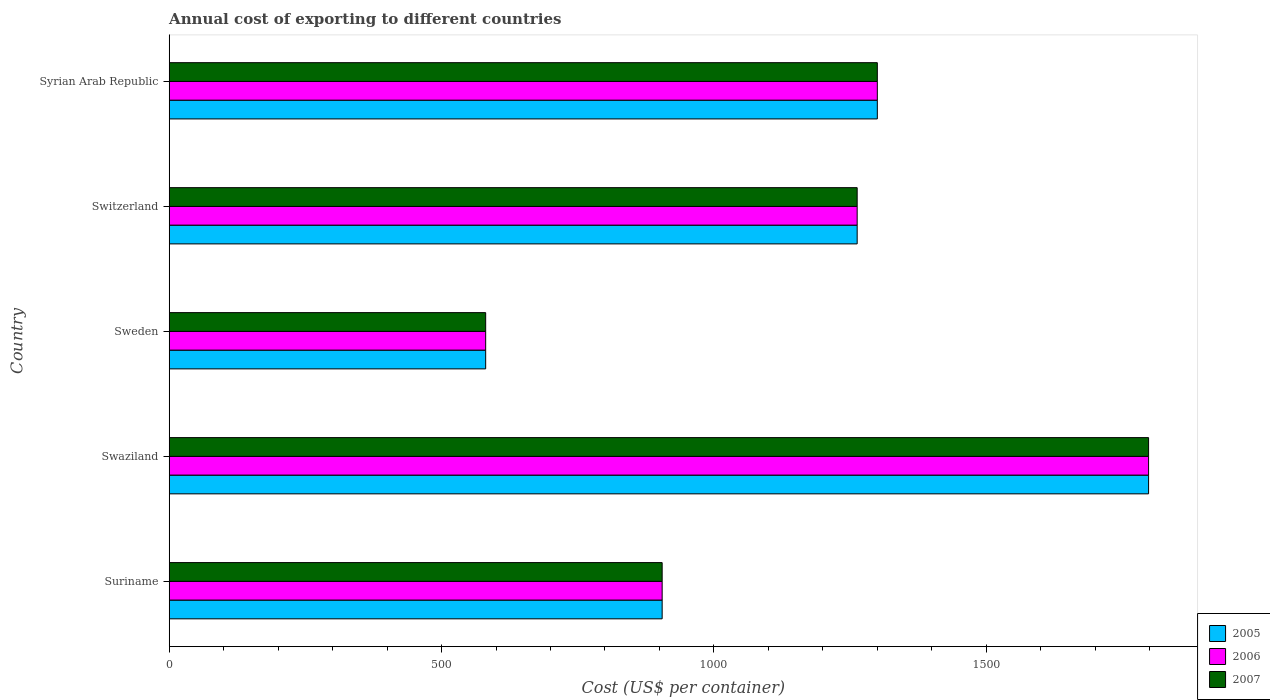Are the number of bars per tick equal to the number of legend labels?
Ensure brevity in your answer.  Yes. How many bars are there on the 3rd tick from the top?
Your response must be concise. 3. How many bars are there on the 5th tick from the bottom?
Your answer should be very brief. 3. In how many cases, is the number of bars for a given country not equal to the number of legend labels?
Provide a succinct answer. 0. What is the total annual cost of exporting in 2005 in Sweden?
Your response must be concise. 581. Across all countries, what is the maximum total annual cost of exporting in 2006?
Your response must be concise. 1798. Across all countries, what is the minimum total annual cost of exporting in 2006?
Your answer should be compact. 581. In which country was the total annual cost of exporting in 2007 maximum?
Ensure brevity in your answer.  Swaziland. What is the total total annual cost of exporting in 2005 in the graph?
Provide a succinct answer. 5847. What is the difference between the total annual cost of exporting in 2007 in Switzerland and that in Syrian Arab Republic?
Provide a succinct answer. -37. What is the difference between the total annual cost of exporting in 2006 in Swaziland and the total annual cost of exporting in 2005 in Sweden?
Offer a terse response. 1217. What is the average total annual cost of exporting in 2006 per country?
Keep it short and to the point. 1169.4. What is the difference between the total annual cost of exporting in 2005 and total annual cost of exporting in 2007 in Sweden?
Provide a succinct answer. 0. In how many countries, is the total annual cost of exporting in 2007 greater than 1600 US$?
Provide a succinct answer. 1. What is the ratio of the total annual cost of exporting in 2005 in Switzerland to that in Syrian Arab Republic?
Provide a short and direct response. 0.97. Is the total annual cost of exporting in 2007 in Suriname less than that in Swaziland?
Your response must be concise. Yes. Is the difference between the total annual cost of exporting in 2005 in Suriname and Syrian Arab Republic greater than the difference between the total annual cost of exporting in 2007 in Suriname and Syrian Arab Republic?
Offer a terse response. No. What is the difference between the highest and the second highest total annual cost of exporting in 2006?
Provide a short and direct response. 498. What is the difference between the highest and the lowest total annual cost of exporting in 2007?
Make the answer very short. 1217. In how many countries, is the total annual cost of exporting in 2005 greater than the average total annual cost of exporting in 2005 taken over all countries?
Provide a succinct answer. 3. Is the sum of the total annual cost of exporting in 2007 in Suriname and Sweden greater than the maximum total annual cost of exporting in 2005 across all countries?
Your answer should be compact. No. What does the 3rd bar from the top in Switzerland represents?
Your answer should be very brief. 2005. What does the 2nd bar from the bottom in Switzerland represents?
Your answer should be very brief. 2006. Does the graph contain any zero values?
Provide a succinct answer. No. Does the graph contain grids?
Offer a terse response. No. How are the legend labels stacked?
Keep it short and to the point. Vertical. What is the title of the graph?
Offer a very short reply. Annual cost of exporting to different countries. What is the label or title of the X-axis?
Make the answer very short. Cost (US$ per container). What is the label or title of the Y-axis?
Make the answer very short. Country. What is the Cost (US$ per container) in 2005 in Suriname?
Ensure brevity in your answer.  905. What is the Cost (US$ per container) in 2006 in Suriname?
Give a very brief answer. 905. What is the Cost (US$ per container) of 2007 in Suriname?
Your answer should be compact. 905. What is the Cost (US$ per container) of 2005 in Swaziland?
Ensure brevity in your answer.  1798. What is the Cost (US$ per container) in 2006 in Swaziland?
Offer a very short reply. 1798. What is the Cost (US$ per container) of 2007 in Swaziland?
Keep it short and to the point. 1798. What is the Cost (US$ per container) of 2005 in Sweden?
Offer a terse response. 581. What is the Cost (US$ per container) in 2006 in Sweden?
Your response must be concise. 581. What is the Cost (US$ per container) in 2007 in Sweden?
Your answer should be compact. 581. What is the Cost (US$ per container) in 2005 in Switzerland?
Give a very brief answer. 1263. What is the Cost (US$ per container) in 2006 in Switzerland?
Ensure brevity in your answer.  1263. What is the Cost (US$ per container) of 2007 in Switzerland?
Provide a succinct answer. 1263. What is the Cost (US$ per container) in 2005 in Syrian Arab Republic?
Provide a short and direct response. 1300. What is the Cost (US$ per container) of 2006 in Syrian Arab Republic?
Keep it short and to the point. 1300. What is the Cost (US$ per container) of 2007 in Syrian Arab Republic?
Your response must be concise. 1300. Across all countries, what is the maximum Cost (US$ per container) in 2005?
Give a very brief answer. 1798. Across all countries, what is the maximum Cost (US$ per container) of 2006?
Offer a terse response. 1798. Across all countries, what is the maximum Cost (US$ per container) in 2007?
Keep it short and to the point. 1798. Across all countries, what is the minimum Cost (US$ per container) of 2005?
Make the answer very short. 581. Across all countries, what is the minimum Cost (US$ per container) in 2006?
Offer a very short reply. 581. Across all countries, what is the minimum Cost (US$ per container) of 2007?
Provide a succinct answer. 581. What is the total Cost (US$ per container) in 2005 in the graph?
Ensure brevity in your answer.  5847. What is the total Cost (US$ per container) of 2006 in the graph?
Provide a short and direct response. 5847. What is the total Cost (US$ per container) in 2007 in the graph?
Ensure brevity in your answer.  5847. What is the difference between the Cost (US$ per container) in 2005 in Suriname and that in Swaziland?
Ensure brevity in your answer.  -893. What is the difference between the Cost (US$ per container) of 2006 in Suriname and that in Swaziland?
Provide a short and direct response. -893. What is the difference between the Cost (US$ per container) of 2007 in Suriname and that in Swaziland?
Make the answer very short. -893. What is the difference between the Cost (US$ per container) of 2005 in Suriname and that in Sweden?
Keep it short and to the point. 324. What is the difference between the Cost (US$ per container) in 2006 in Suriname and that in Sweden?
Provide a succinct answer. 324. What is the difference between the Cost (US$ per container) in 2007 in Suriname and that in Sweden?
Keep it short and to the point. 324. What is the difference between the Cost (US$ per container) in 2005 in Suriname and that in Switzerland?
Ensure brevity in your answer.  -358. What is the difference between the Cost (US$ per container) in 2006 in Suriname and that in Switzerland?
Give a very brief answer. -358. What is the difference between the Cost (US$ per container) in 2007 in Suriname and that in Switzerland?
Ensure brevity in your answer.  -358. What is the difference between the Cost (US$ per container) in 2005 in Suriname and that in Syrian Arab Republic?
Make the answer very short. -395. What is the difference between the Cost (US$ per container) in 2006 in Suriname and that in Syrian Arab Republic?
Make the answer very short. -395. What is the difference between the Cost (US$ per container) of 2007 in Suriname and that in Syrian Arab Republic?
Provide a short and direct response. -395. What is the difference between the Cost (US$ per container) of 2005 in Swaziland and that in Sweden?
Offer a very short reply. 1217. What is the difference between the Cost (US$ per container) in 2006 in Swaziland and that in Sweden?
Provide a short and direct response. 1217. What is the difference between the Cost (US$ per container) of 2007 in Swaziland and that in Sweden?
Your answer should be very brief. 1217. What is the difference between the Cost (US$ per container) of 2005 in Swaziland and that in Switzerland?
Your answer should be very brief. 535. What is the difference between the Cost (US$ per container) in 2006 in Swaziland and that in Switzerland?
Offer a terse response. 535. What is the difference between the Cost (US$ per container) of 2007 in Swaziland and that in Switzerland?
Your response must be concise. 535. What is the difference between the Cost (US$ per container) in 2005 in Swaziland and that in Syrian Arab Republic?
Offer a very short reply. 498. What is the difference between the Cost (US$ per container) of 2006 in Swaziland and that in Syrian Arab Republic?
Provide a short and direct response. 498. What is the difference between the Cost (US$ per container) of 2007 in Swaziland and that in Syrian Arab Republic?
Keep it short and to the point. 498. What is the difference between the Cost (US$ per container) in 2005 in Sweden and that in Switzerland?
Your answer should be compact. -682. What is the difference between the Cost (US$ per container) of 2006 in Sweden and that in Switzerland?
Keep it short and to the point. -682. What is the difference between the Cost (US$ per container) of 2007 in Sweden and that in Switzerland?
Your answer should be compact. -682. What is the difference between the Cost (US$ per container) of 2005 in Sweden and that in Syrian Arab Republic?
Give a very brief answer. -719. What is the difference between the Cost (US$ per container) in 2006 in Sweden and that in Syrian Arab Republic?
Offer a terse response. -719. What is the difference between the Cost (US$ per container) in 2007 in Sweden and that in Syrian Arab Republic?
Ensure brevity in your answer.  -719. What is the difference between the Cost (US$ per container) of 2005 in Switzerland and that in Syrian Arab Republic?
Make the answer very short. -37. What is the difference between the Cost (US$ per container) of 2006 in Switzerland and that in Syrian Arab Republic?
Your answer should be very brief. -37. What is the difference between the Cost (US$ per container) of 2007 in Switzerland and that in Syrian Arab Republic?
Provide a short and direct response. -37. What is the difference between the Cost (US$ per container) in 2005 in Suriname and the Cost (US$ per container) in 2006 in Swaziland?
Your answer should be compact. -893. What is the difference between the Cost (US$ per container) of 2005 in Suriname and the Cost (US$ per container) of 2007 in Swaziland?
Your answer should be very brief. -893. What is the difference between the Cost (US$ per container) in 2006 in Suriname and the Cost (US$ per container) in 2007 in Swaziland?
Give a very brief answer. -893. What is the difference between the Cost (US$ per container) of 2005 in Suriname and the Cost (US$ per container) of 2006 in Sweden?
Ensure brevity in your answer.  324. What is the difference between the Cost (US$ per container) in 2005 in Suriname and the Cost (US$ per container) in 2007 in Sweden?
Your answer should be very brief. 324. What is the difference between the Cost (US$ per container) in 2006 in Suriname and the Cost (US$ per container) in 2007 in Sweden?
Provide a succinct answer. 324. What is the difference between the Cost (US$ per container) of 2005 in Suriname and the Cost (US$ per container) of 2006 in Switzerland?
Keep it short and to the point. -358. What is the difference between the Cost (US$ per container) in 2005 in Suriname and the Cost (US$ per container) in 2007 in Switzerland?
Keep it short and to the point. -358. What is the difference between the Cost (US$ per container) of 2006 in Suriname and the Cost (US$ per container) of 2007 in Switzerland?
Offer a very short reply. -358. What is the difference between the Cost (US$ per container) of 2005 in Suriname and the Cost (US$ per container) of 2006 in Syrian Arab Republic?
Offer a very short reply. -395. What is the difference between the Cost (US$ per container) in 2005 in Suriname and the Cost (US$ per container) in 2007 in Syrian Arab Republic?
Keep it short and to the point. -395. What is the difference between the Cost (US$ per container) of 2006 in Suriname and the Cost (US$ per container) of 2007 in Syrian Arab Republic?
Make the answer very short. -395. What is the difference between the Cost (US$ per container) in 2005 in Swaziland and the Cost (US$ per container) in 2006 in Sweden?
Keep it short and to the point. 1217. What is the difference between the Cost (US$ per container) of 2005 in Swaziland and the Cost (US$ per container) of 2007 in Sweden?
Ensure brevity in your answer.  1217. What is the difference between the Cost (US$ per container) in 2006 in Swaziland and the Cost (US$ per container) in 2007 in Sweden?
Give a very brief answer. 1217. What is the difference between the Cost (US$ per container) of 2005 in Swaziland and the Cost (US$ per container) of 2006 in Switzerland?
Keep it short and to the point. 535. What is the difference between the Cost (US$ per container) in 2005 in Swaziland and the Cost (US$ per container) in 2007 in Switzerland?
Your response must be concise. 535. What is the difference between the Cost (US$ per container) of 2006 in Swaziland and the Cost (US$ per container) of 2007 in Switzerland?
Your response must be concise. 535. What is the difference between the Cost (US$ per container) of 2005 in Swaziland and the Cost (US$ per container) of 2006 in Syrian Arab Republic?
Make the answer very short. 498. What is the difference between the Cost (US$ per container) of 2005 in Swaziland and the Cost (US$ per container) of 2007 in Syrian Arab Republic?
Offer a terse response. 498. What is the difference between the Cost (US$ per container) of 2006 in Swaziland and the Cost (US$ per container) of 2007 in Syrian Arab Republic?
Provide a succinct answer. 498. What is the difference between the Cost (US$ per container) in 2005 in Sweden and the Cost (US$ per container) in 2006 in Switzerland?
Provide a short and direct response. -682. What is the difference between the Cost (US$ per container) in 2005 in Sweden and the Cost (US$ per container) in 2007 in Switzerland?
Your response must be concise. -682. What is the difference between the Cost (US$ per container) in 2006 in Sweden and the Cost (US$ per container) in 2007 in Switzerland?
Make the answer very short. -682. What is the difference between the Cost (US$ per container) of 2005 in Sweden and the Cost (US$ per container) of 2006 in Syrian Arab Republic?
Offer a terse response. -719. What is the difference between the Cost (US$ per container) in 2005 in Sweden and the Cost (US$ per container) in 2007 in Syrian Arab Republic?
Give a very brief answer. -719. What is the difference between the Cost (US$ per container) of 2006 in Sweden and the Cost (US$ per container) of 2007 in Syrian Arab Republic?
Ensure brevity in your answer.  -719. What is the difference between the Cost (US$ per container) in 2005 in Switzerland and the Cost (US$ per container) in 2006 in Syrian Arab Republic?
Your answer should be very brief. -37. What is the difference between the Cost (US$ per container) of 2005 in Switzerland and the Cost (US$ per container) of 2007 in Syrian Arab Republic?
Offer a terse response. -37. What is the difference between the Cost (US$ per container) of 2006 in Switzerland and the Cost (US$ per container) of 2007 in Syrian Arab Republic?
Your response must be concise. -37. What is the average Cost (US$ per container) in 2005 per country?
Give a very brief answer. 1169.4. What is the average Cost (US$ per container) in 2006 per country?
Give a very brief answer. 1169.4. What is the average Cost (US$ per container) of 2007 per country?
Offer a very short reply. 1169.4. What is the difference between the Cost (US$ per container) of 2005 and Cost (US$ per container) of 2006 in Suriname?
Ensure brevity in your answer.  0. What is the difference between the Cost (US$ per container) of 2005 and Cost (US$ per container) of 2007 in Suriname?
Your answer should be compact. 0. What is the difference between the Cost (US$ per container) of 2006 and Cost (US$ per container) of 2007 in Suriname?
Your answer should be very brief. 0. What is the difference between the Cost (US$ per container) in 2005 and Cost (US$ per container) in 2007 in Swaziland?
Your response must be concise. 0. What is the difference between the Cost (US$ per container) of 2005 and Cost (US$ per container) of 2006 in Sweden?
Your answer should be very brief. 0. What is the difference between the Cost (US$ per container) of 2005 and Cost (US$ per container) of 2006 in Switzerland?
Offer a terse response. 0. What is the difference between the Cost (US$ per container) of 2005 and Cost (US$ per container) of 2006 in Syrian Arab Republic?
Offer a very short reply. 0. What is the difference between the Cost (US$ per container) of 2005 and Cost (US$ per container) of 2007 in Syrian Arab Republic?
Keep it short and to the point. 0. What is the difference between the Cost (US$ per container) in 2006 and Cost (US$ per container) in 2007 in Syrian Arab Republic?
Ensure brevity in your answer.  0. What is the ratio of the Cost (US$ per container) of 2005 in Suriname to that in Swaziland?
Your response must be concise. 0.5. What is the ratio of the Cost (US$ per container) of 2006 in Suriname to that in Swaziland?
Make the answer very short. 0.5. What is the ratio of the Cost (US$ per container) of 2007 in Suriname to that in Swaziland?
Keep it short and to the point. 0.5. What is the ratio of the Cost (US$ per container) in 2005 in Suriname to that in Sweden?
Provide a succinct answer. 1.56. What is the ratio of the Cost (US$ per container) of 2006 in Suriname to that in Sweden?
Offer a very short reply. 1.56. What is the ratio of the Cost (US$ per container) in 2007 in Suriname to that in Sweden?
Your answer should be very brief. 1.56. What is the ratio of the Cost (US$ per container) of 2005 in Suriname to that in Switzerland?
Provide a succinct answer. 0.72. What is the ratio of the Cost (US$ per container) in 2006 in Suriname to that in Switzerland?
Give a very brief answer. 0.72. What is the ratio of the Cost (US$ per container) of 2007 in Suriname to that in Switzerland?
Your answer should be very brief. 0.72. What is the ratio of the Cost (US$ per container) in 2005 in Suriname to that in Syrian Arab Republic?
Offer a terse response. 0.7. What is the ratio of the Cost (US$ per container) of 2006 in Suriname to that in Syrian Arab Republic?
Your answer should be very brief. 0.7. What is the ratio of the Cost (US$ per container) of 2007 in Suriname to that in Syrian Arab Republic?
Ensure brevity in your answer.  0.7. What is the ratio of the Cost (US$ per container) in 2005 in Swaziland to that in Sweden?
Ensure brevity in your answer.  3.09. What is the ratio of the Cost (US$ per container) in 2006 in Swaziland to that in Sweden?
Ensure brevity in your answer.  3.09. What is the ratio of the Cost (US$ per container) in 2007 in Swaziland to that in Sweden?
Your answer should be very brief. 3.09. What is the ratio of the Cost (US$ per container) of 2005 in Swaziland to that in Switzerland?
Provide a short and direct response. 1.42. What is the ratio of the Cost (US$ per container) of 2006 in Swaziland to that in Switzerland?
Provide a succinct answer. 1.42. What is the ratio of the Cost (US$ per container) of 2007 in Swaziland to that in Switzerland?
Provide a succinct answer. 1.42. What is the ratio of the Cost (US$ per container) of 2005 in Swaziland to that in Syrian Arab Republic?
Offer a very short reply. 1.38. What is the ratio of the Cost (US$ per container) in 2006 in Swaziland to that in Syrian Arab Republic?
Offer a very short reply. 1.38. What is the ratio of the Cost (US$ per container) of 2007 in Swaziland to that in Syrian Arab Republic?
Offer a very short reply. 1.38. What is the ratio of the Cost (US$ per container) of 2005 in Sweden to that in Switzerland?
Give a very brief answer. 0.46. What is the ratio of the Cost (US$ per container) of 2006 in Sweden to that in Switzerland?
Provide a short and direct response. 0.46. What is the ratio of the Cost (US$ per container) of 2007 in Sweden to that in Switzerland?
Your answer should be very brief. 0.46. What is the ratio of the Cost (US$ per container) of 2005 in Sweden to that in Syrian Arab Republic?
Keep it short and to the point. 0.45. What is the ratio of the Cost (US$ per container) of 2006 in Sweden to that in Syrian Arab Republic?
Make the answer very short. 0.45. What is the ratio of the Cost (US$ per container) in 2007 in Sweden to that in Syrian Arab Republic?
Your response must be concise. 0.45. What is the ratio of the Cost (US$ per container) of 2005 in Switzerland to that in Syrian Arab Republic?
Provide a short and direct response. 0.97. What is the ratio of the Cost (US$ per container) of 2006 in Switzerland to that in Syrian Arab Republic?
Your response must be concise. 0.97. What is the ratio of the Cost (US$ per container) in 2007 in Switzerland to that in Syrian Arab Republic?
Give a very brief answer. 0.97. What is the difference between the highest and the second highest Cost (US$ per container) of 2005?
Offer a terse response. 498. What is the difference between the highest and the second highest Cost (US$ per container) of 2006?
Ensure brevity in your answer.  498. What is the difference between the highest and the second highest Cost (US$ per container) in 2007?
Give a very brief answer. 498. What is the difference between the highest and the lowest Cost (US$ per container) of 2005?
Your response must be concise. 1217. What is the difference between the highest and the lowest Cost (US$ per container) in 2006?
Offer a terse response. 1217. What is the difference between the highest and the lowest Cost (US$ per container) in 2007?
Give a very brief answer. 1217. 